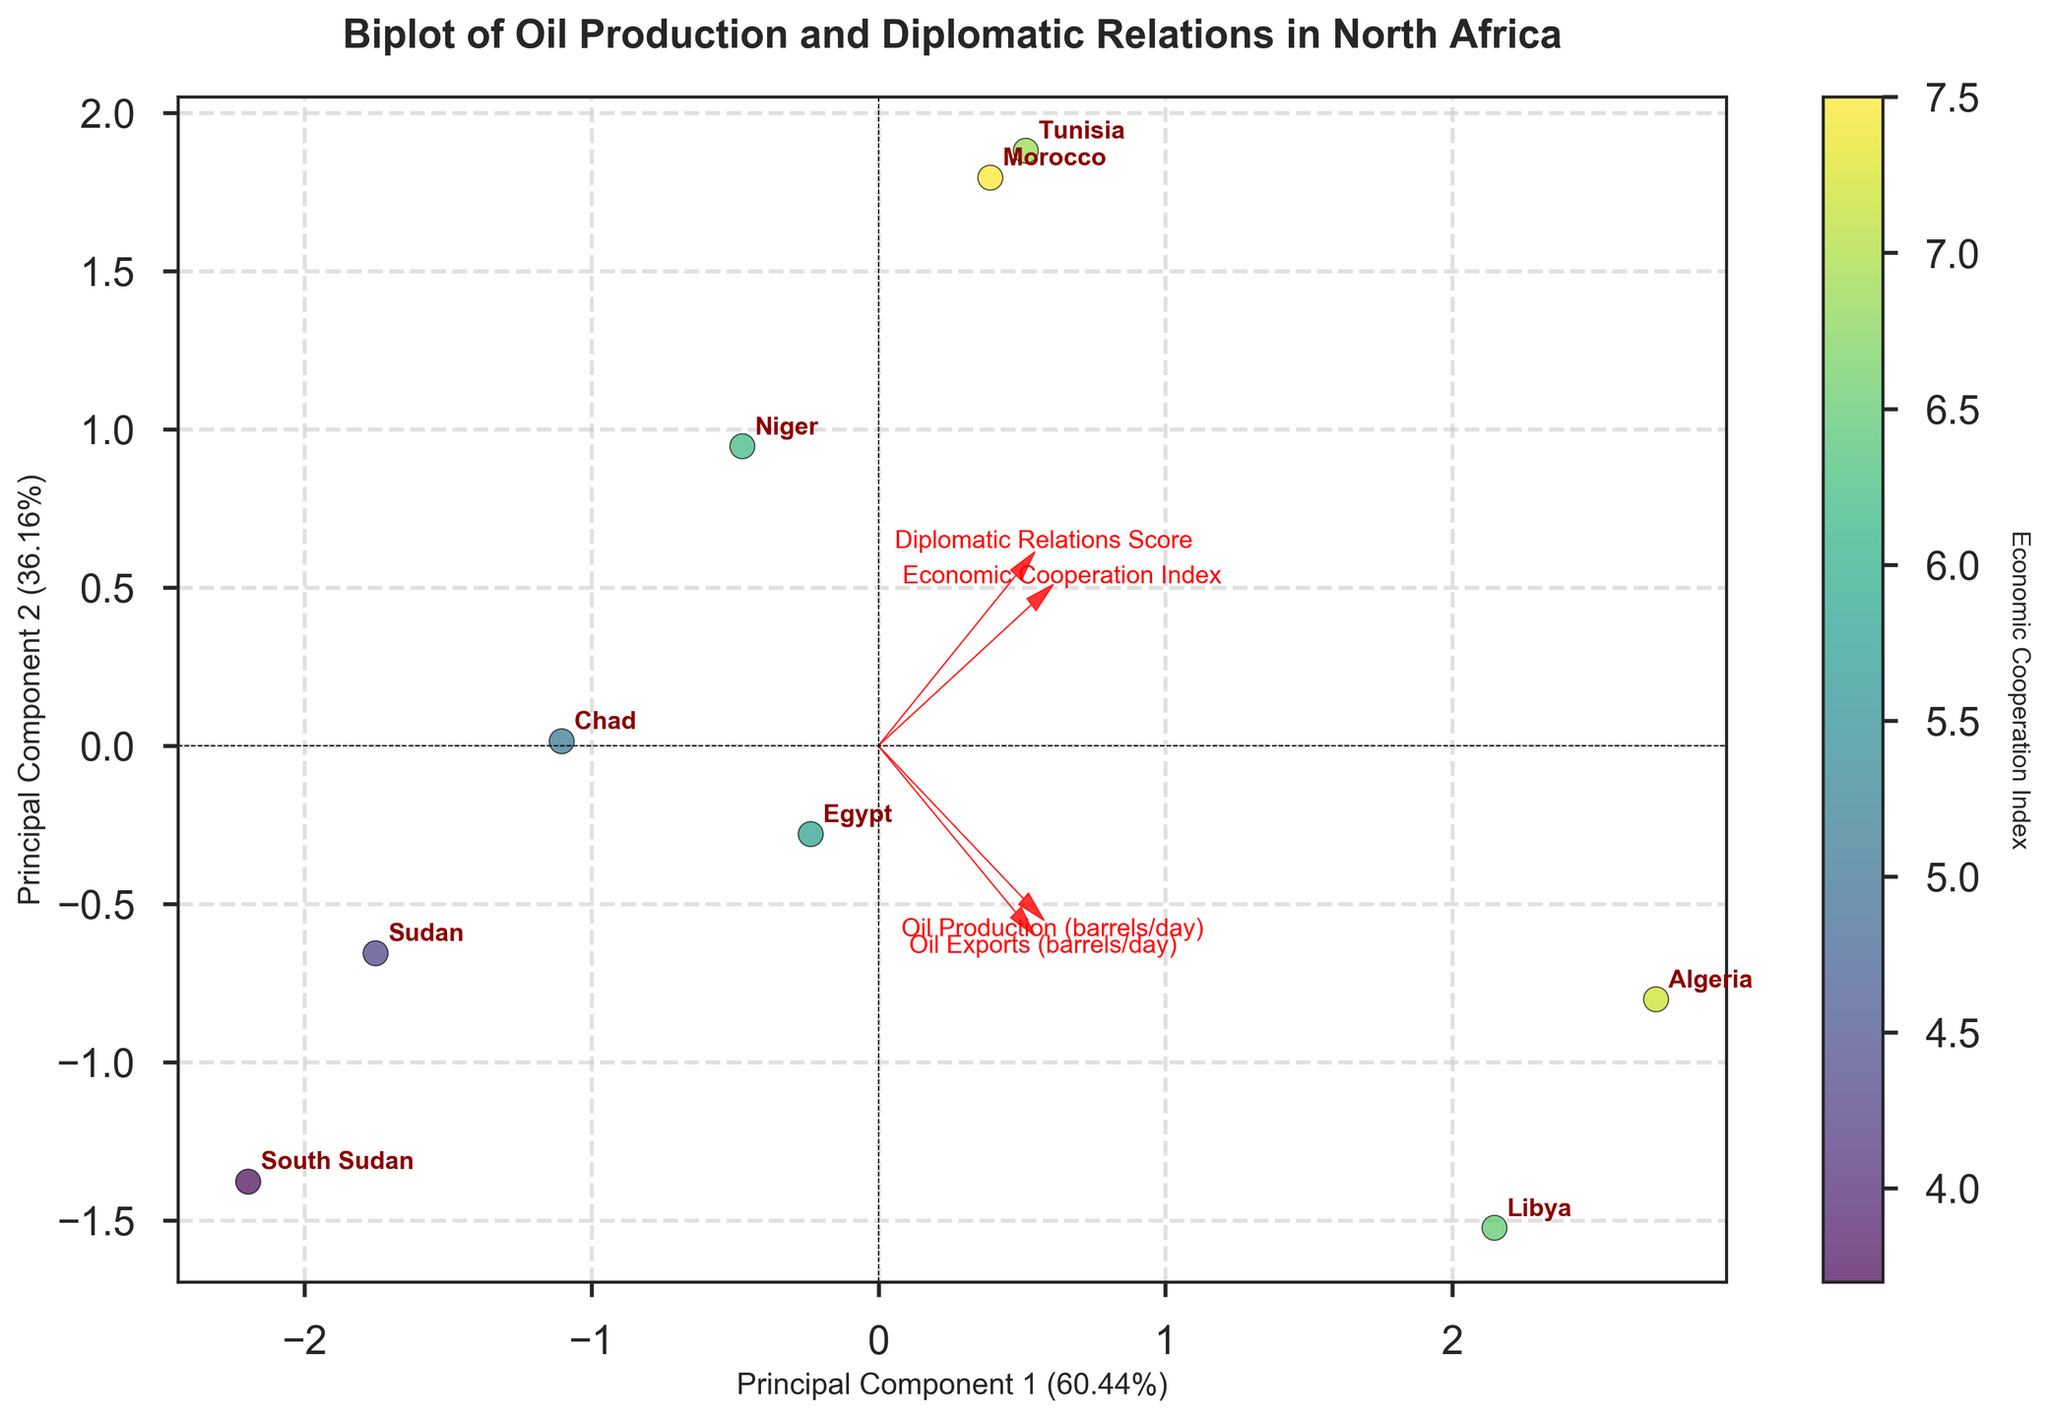What is the title of the figure? The title is located at the top of the biplot. It provides a summary of what the figure represents.
Answer: Biplot of Oil Production and Diplomatic Relations in North Africa Which country has the highest Economic Cooperation Index? The Economic Cooperation Index is color-coded in the biplot, with darker colors representing higher values. The color bar on the right shows the gradient used. Identify the country linked to the darkest point.
Answer: Morocco What is the position of Libya on the biplot relative to the origin? To find Libya's position, locate its label in the biplot and observe its coordinates relative to the x-axis and y-axis from the origin (0, 0).
Answer: Positive x and positive y Which countries have no oil exports according to the biplot? To determine this, locate countries that plot near the "Oil Exports (barrels/day)" arrow in the negative direction.
Answer: Morocco and Niger Which feature has the strongest influence on Principal Component 1? This can be observed by noting the length of the arrows representing each feature along the x-axis. The longest arrow indicates the strongest influence.
Answer: Oil Production (barrels/day) How do Egypt and Sudan compare in terms of their scores on Principal Component 1? Locate the positions of Egypt and Sudan in the biplot. Compare their coordinates on the x-axis to see which country has a higher or lower value on Principal Component 1.
Answer: Egypt has a higher score Which countries are closest to each other on the biplot? Identify pairs of countries that are plotted nearest to each other within the graphical space. Consider both x and y coordinates.
Answer: South Sudan and Chad What does the length of the arrow for "Diplomatic Relations Score" indicate about its variance contribution? The length of the arrow represents its contribution to the variance captured by the principal components. Longer arrows indicate a higher contribution.
Answer: Moderate contribution What is the angle between the arrows representing "Oil Production" and "Economic Cooperation Index," and what does it signify? Observe the angle between the two arrows. A smaller angle (less than 90 degrees) indicates a positive correlation, while an angle greater than 90 degrees indicates a negative correlation.
Answer: Small angle, indicating a positive correlation 